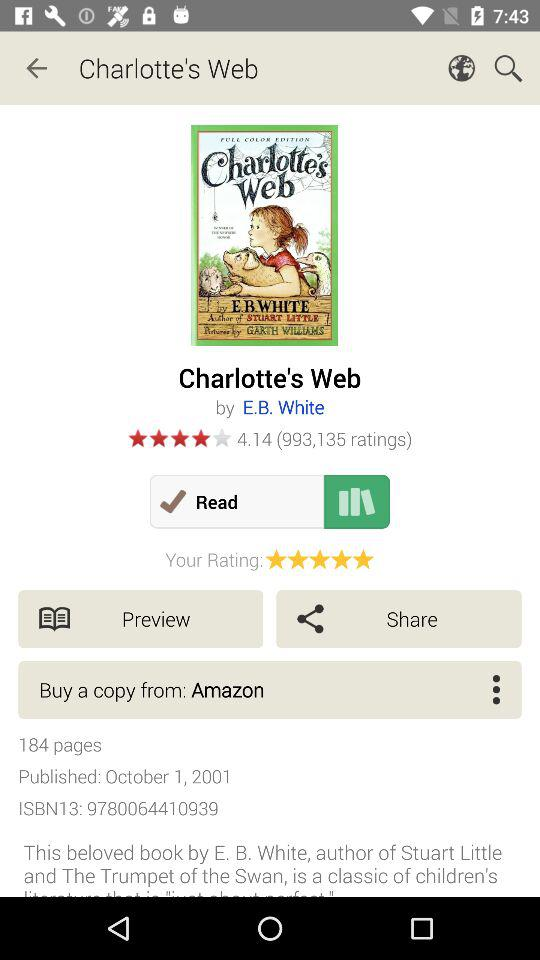What is the rating of the book? The rating is 4.14. 